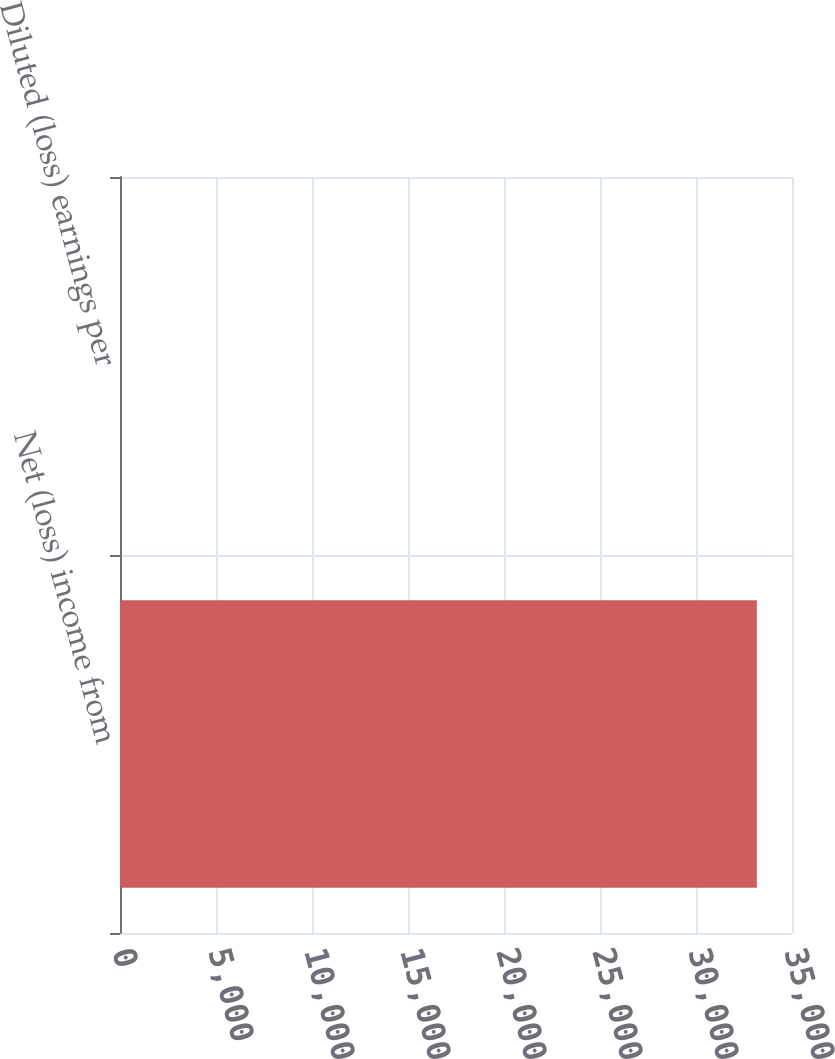Convert chart. <chart><loc_0><loc_0><loc_500><loc_500><bar_chart><fcel>Net (loss) income from<fcel>Diluted (loss) earnings per<nl><fcel>33168<fcel>0.09<nl></chart> 